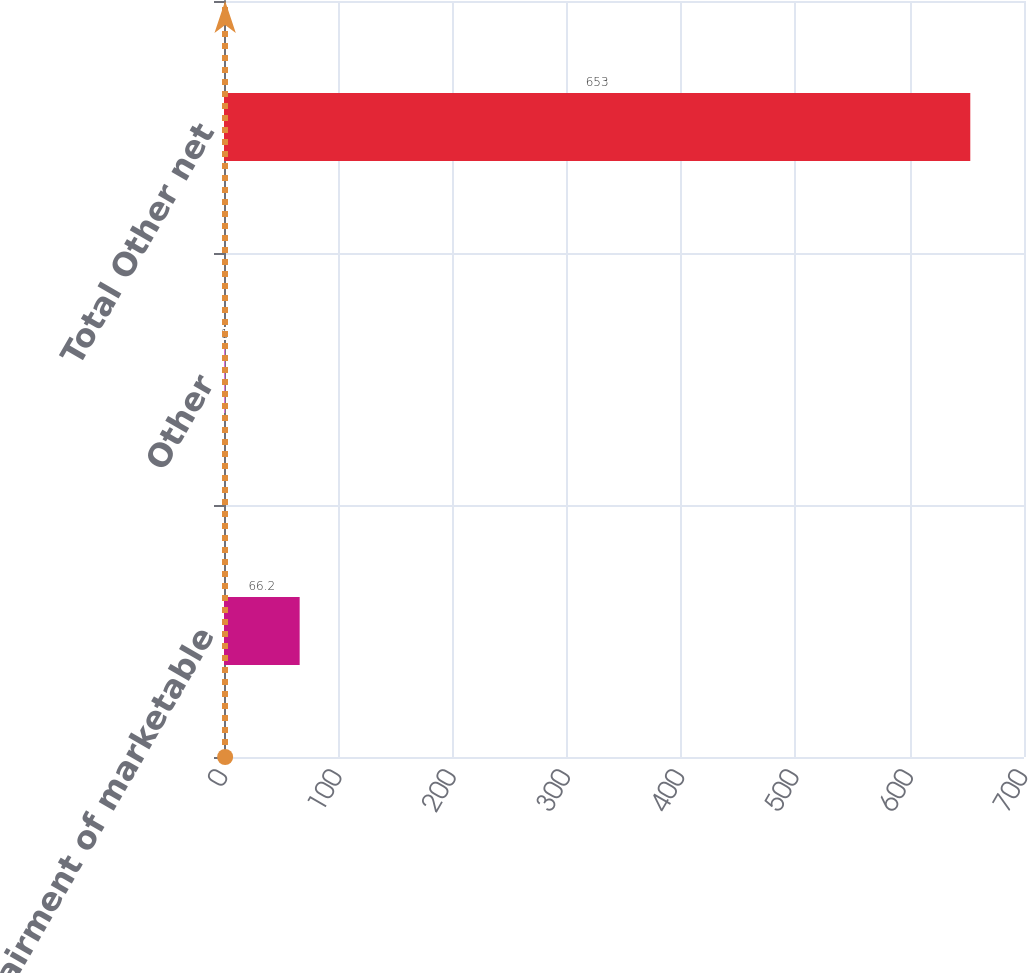<chart> <loc_0><loc_0><loc_500><loc_500><bar_chart><fcel>Impairment of marketable<fcel>Other<fcel>Total Other net<nl><fcel>66.2<fcel>1<fcel>653<nl></chart> 